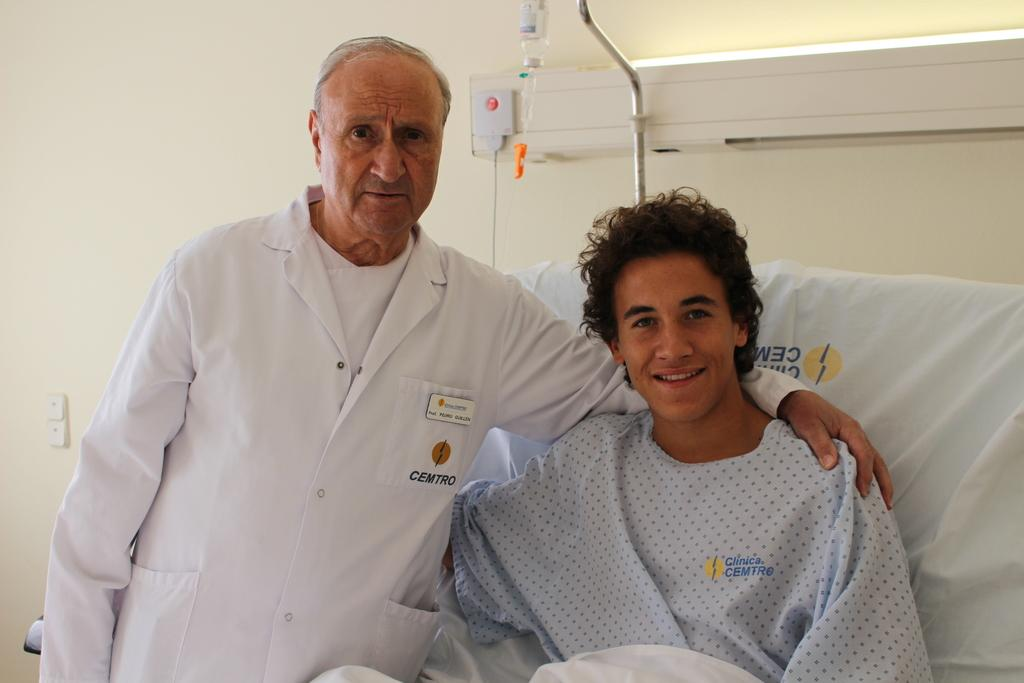What is the position of the person on the right side of the image? There is a person sitting on the bed on the right side of the image. What is the position of the person on the left side of the image? There is a person standing on the floor on the left side of the image. What can be seen behind the people in the image? There is a saline bottle behind the people. What is visible in the background of the image? There is a wall in the background of the image. What type of skin is visible on the turkey in the image? There is no turkey present in the image, and therefore no skin can be observed. How many ducks are visible in the image? There are no ducks present in the image. 